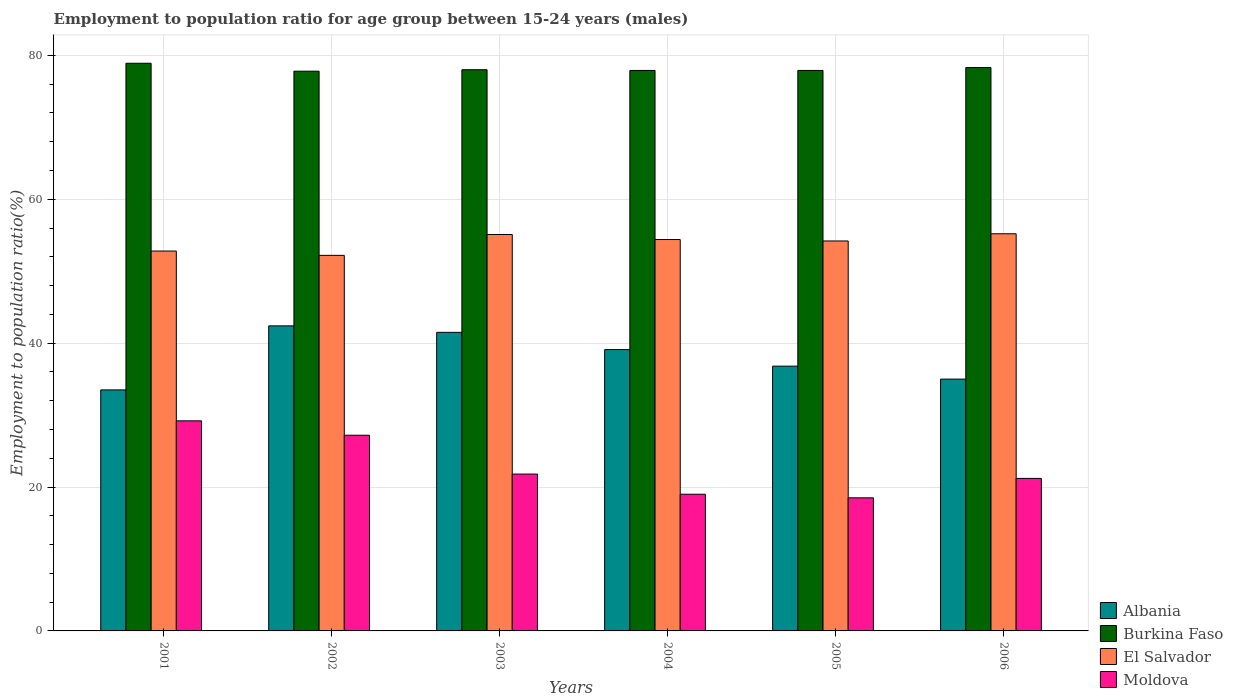How many different coloured bars are there?
Your response must be concise. 4. Are the number of bars per tick equal to the number of legend labels?
Your response must be concise. Yes. Are the number of bars on each tick of the X-axis equal?
Your answer should be very brief. Yes. How many bars are there on the 6th tick from the left?
Your response must be concise. 4. How many bars are there on the 1st tick from the right?
Give a very brief answer. 4. What is the employment to population ratio in Moldova in 2001?
Give a very brief answer. 29.2. Across all years, what is the maximum employment to population ratio in Burkina Faso?
Give a very brief answer. 78.9. Across all years, what is the minimum employment to population ratio in El Salvador?
Your answer should be very brief. 52.2. In which year was the employment to population ratio in Albania maximum?
Your response must be concise. 2002. In which year was the employment to population ratio in Moldova minimum?
Keep it short and to the point. 2005. What is the total employment to population ratio in Albania in the graph?
Offer a very short reply. 228.3. What is the difference between the employment to population ratio in El Salvador in 2001 and that in 2005?
Your response must be concise. -1.4. What is the difference between the employment to population ratio in Moldova in 2003 and the employment to population ratio in Burkina Faso in 2002?
Make the answer very short. -56. What is the average employment to population ratio in Albania per year?
Make the answer very short. 38.05. In the year 2005, what is the difference between the employment to population ratio in Burkina Faso and employment to population ratio in Moldova?
Provide a succinct answer. 59.4. What is the ratio of the employment to population ratio in Burkina Faso in 2001 to that in 2006?
Your answer should be very brief. 1.01. What is the difference between the highest and the second highest employment to population ratio in El Salvador?
Your answer should be very brief. 0.1. What is the difference between the highest and the lowest employment to population ratio in Albania?
Provide a short and direct response. 8.9. In how many years, is the employment to population ratio in Burkina Faso greater than the average employment to population ratio in Burkina Faso taken over all years?
Make the answer very short. 2. What does the 4th bar from the left in 2001 represents?
Offer a very short reply. Moldova. What does the 4th bar from the right in 2005 represents?
Offer a very short reply. Albania. How many bars are there?
Ensure brevity in your answer.  24. Are all the bars in the graph horizontal?
Your response must be concise. No. How many years are there in the graph?
Provide a succinct answer. 6. Are the values on the major ticks of Y-axis written in scientific E-notation?
Provide a short and direct response. No. Does the graph contain any zero values?
Offer a very short reply. No. Does the graph contain grids?
Your answer should be compact. Yes. What is the title of the graph?
Provide a short and direct response. Employment to population ratio for age group between 15-24 years (males). What is the label or title of the X-axis?
Your answer should be very brief. Years. What is the label or title of the Y-axis?
Give a very brief answer. Employment to population ratio(%). What is the Employment to population ratio(%) in Albania in 2001?
Provide a short and direct response. 33.5. What is the Employment to population ratio(%) in Burkina Faso in 2001?
Ensure brevity in your answer.  78.9. What is the Employment to population ratio(%) of El Salvador in 2001?
Offer a terse response. 52.8. What is the Employment to population ratio(%) in Moldova in 2001?
Provide a succinct answer. 29.2. What is the Employment to population ratio(%) of Albania in 2002?
Your answer should be compact. 42.4. What is the Employment to population ratio(%) of Burkina Faso in 2002?
Provide a short and direct response. 77.8. What is the Employment to population ratio(%) of El Salvador in 2002?
Your answer should be compact. 52.2. What is the Employment to population ratio(%) of Moldova in 2002?
Make the answer very short. 27.2. What is the Employment to population ratio(%) in Albania in 2003?
Keep it short and to the point. 41.5. What is the Employment to population ratio(%) in Burkina Faso in 2003?
Your answer should be very brief. 78. What is the Employment to population ratio(%) of El Salvador in 2003?
Offer a terse response. 55.1. What is the Employment to population ratio(%) of Moldova in 2003?
Keep it short and to the point. 21.8. What is the Employment to population ratio(%) of Albania in 2004?
Make the answer very short. 39.1. What is the Employment to population ratio(%) of Burkina Faso in 2004?
Your response must be concise. 77.9. What is the Employment to population ratio(%) of El Salvador in 2004?
Provide a short and direct response. 54.4. What is the Employment to population ratio(%) in Moldova in 2004?
Your response must be concise. 19. What is the Employment to population ratio(%) in Albania in 2005?
Give a very brief answer. 36.8. What is the Employment to population ratio(%) in Burkina Faso in 2005?
Keep it short and to the point. 77.9. What is the Employment to population ratio(%) of El Salvador in 2005?
Your answer should be very brief. 54.2. What is the Employment to population ratio(%) in Albania in 2006?
Make the answer very short. 35. What is the Employment to population ratio(%) in Burkina Faso in 2006?
Keep it short and to the point. 78.3. What is the Employment to population ratio(%) in El Salvador in 2006?
Make the answer very short. 55.2. What is the Employment to population ratio(%) in Moldova in 2006?
Your answer should be compact. 21.2. Across all years, what is the maximum Employment to population ratio(%) of Albania?
Make the answer very short. 42.4. Across all years, what is the maximum Employment to population ratio(%) of Burkina Faso?
Give a very brief answer. 78.9. Across all years, what is the maximum Employment to population ratio(%) of El Salvador?
Provide a short and direct response. 55.2. Across all years, what is the maximum Employment to population ratio(%) in Moldova?
Make the answer very short. 29.2. Across all years, what is the minimum Employment to population ratio(%) of Albania?
Offer a very short reply. 33.5. Across all years, what is the minimum Employment to population ratio(%) in Burkina Faso?
Ensure brevity in your answer.  77.8. Across all years, what is the minimum Employment to population ratio(%) of El Salvador?
Your answer should be compact. 52.2. What is the total Employment to population ratio(%) of Albania in the graph?
Your response must be concise. 228.3. What is the total Employment to population ratio(%) of Burkina Faso in the graph?
Offer a very short reply. 468.8. What is the total Employment to population ratio(%) in El Salvador in the graph?
Your answer should be compact. 323.9. What is the total Employment to population ratio(%) in Moldova in the graph?
Give a very brief answer. 136.9. What is the difference between the Employment to population ratio(%) of Albania in 2001 and that in 2002?
Your answer should be very brief. -8.9. What is the difference between the Employment to population ratio(%) of Burkina Faso in 2001 and that in 2002?
Keep it short and to the point. 1.1. What is the difference between the Employment to population ratio(%) in Albania in 2001 and that in 2003?
Provide a short and direct response. -8. What is the difference between the Employment to population ratio(%) in El Salvador in 2001 and that in 2003?
Your response must be concise. -2.3. What is the difference between the Employment to population ratio(%) in Albania in 2001 and that in 2004?
Your answer should be very brief. -5.6. What is the difference between the Employment to population ratio(%) in Burkina Faso in 2001 and that in 2005?
Provide a succinct answer. 1. What is the difference between the Employment to population ratio(%) of Moldova in 2001 and that in 2005?
Provide a short and direct response. 10.7. What is the difference between the Employment to population ratio(%) in El Salvador in 2001 and that in 2006?
Provide a short and direct response. -2.4. What is the difference between the Employment to population ratio(%) of Burkina Faso in 2002 and that in 2003?
Keep it short and to the point. -0.2. What is the difference between the Employment to population ratio(%) of Albania in 2002 and that in 2004?
Make the answer very short. 3.3. What is the difference between the Employment to population ratio(%) of El Salvador in 2002 and that in 2004?
Offer a very short reply. -2.2. What is the difference between the Employment to population ratio(%) of Moldova in 2002 and that in 2004?
Provide a short and direct response. 8.2. What is the difference between the Employment to population ratio(%) of Burkina Faso in 2002 and that in 2005?
Provide a succinct answer. -0.1. What is the difference between the Employment to population ratio(%) in El Salvador in 2002 and that in 2006?
Offer a very short reply. -3. What is the difference between the Employment to population ratio(%) of Moldova in 2002 and that in 2006?
Offer a very short reply. 6. What is the difference between the Employment to population ratio(%) of Albania in 2003 and that in 2004?
Keep it short and to the point. 2.4. What is the difference between the Employment to population ratio(%) in Albania in 2003 and that in 2005?
Your answer should be very brief. 4.7. What is the difference between the Employment to population ratio(%) in Moldova in 2003 and that in 2005?
Offer a terse response. 3.3. What is the difference between the Employment to population ratio(%) of Albania in 2003 and that in 2006?
Your answer should be very brief. 6.5. What is the difference between the Employment to population ratio(%) in Burkina Faso in 2003 and that in 2006?
Provide a succinct answer. -0.3. What is the difference between the Employment to population ratio(%) in El Salvador in 2003 and that in 2006?
Offer a very short reply. -0.1. What is the difference between the Employment to population ratio(%) in Albania in 2004 and that in 2005?
Give a very brief answer. 2.3. What is the difference between the Employment to population ratio(%) of Moldova in 2004 and that in 2005?
Ensure brevity in your answer.  0.5. What is the difference between the Employment to population ratio(%) of Burkina Faso in 2004 and that in 2006?
Offer a very short reply. -0.4. What is the difference between the Employment to population ratio(%) of El Salvador in 2004 and that in 2006?
Your answer should be compact. -0.8. What is the difference between the Employment to population ratio(%) of Albania in 2005 and that in 2006?
Keep it short and to the point. 1.8. What is the difference between the Employment to population ratio(%) in Burkina Faso in 2005 and that in 2006?
Offer a very short reply. -0.4. What is the difference between the Employment to population ratio(%) of Moldova in 2005 and that in 2006?
Offer a very short reply. -2.7. What is the difference between the Employment to population ratio(%) in Albania in 2001 and the Employment to population ratio(%) in Burkina Faso in 2002?
Your answer should be compact. -44.3. What is the difference between the Employment to population ratio(%) of Albania in 2001 and the Employment to population ratio(%) of El Salvador in 2002?
Make the answer very short. -18.7. What is the difference between the Employment to population ratio(%) in Albania in 2001 and the Employment to population ratio(%) in Moldova in 2002?
Offer a very short reply. 6.3. What is the difference between the Employment to population ratio(%) in Burkina Faso in 2001 and the Employment to population ratio(%) in El Salvador in 2002?
Your answer should be compact. 26.7. What is the difference between the Employment to population ratio(%) of Burkina Faso in 2001 and the Employment to population ratio(%) of Moldova in 2002?
Offer a terse response. 51.7. What is the difference between the Employment to population ratio(%) of El Salvador in 2001 and the Employment to population ratio(%) of Moldova in 2002?
Offer a terse response. 25.6. What is the difference between the Employment to population ratio(%) in Albania in 2001 and the Employment to population ratio(%) in Burkina Faso in 2003?
Your response must be concise. -44.5. What is the difference between the Employment to population ratio(%) in Albania in 2001 and the Employment to population ratio(%) in El Salvador in 2003?
Your answer should be very brief. -21.6. What is the difference between the Employment to population ratio(%) in Albania in 2001 and the Employment to population ratio(%) in Moldova in 2003?
Ensure brevity in your answer.  11.7. What is the difference between the Employment to population ratio(%) in Burkina Faso in 2001 and the Employment to population ratio(%) in El Salvador in 2003?
Your response must be concise. 23.8. What is the difference between the Employment to population ratio(%) in Burkina Faso in 2001 and the Employment to population ratio(%) in Moldova in 2003?
Your answer should be very brief. 57.1. What is the difference between the Employment to population ratio(%) of Albania in 2001 and the Employment to population ratio(%) of Burkina Faso in 2004?
Offer a very short reply. -44.4. What is the difference between the Employment to population ratio(%) in Albania in 2001 and the Employment to population ratio(%) in El Salvador in 2004?
Make the answer very short. -20.9. What is the difference between the Employment to population ratio(%) of Burkina Faso in 2001 and the Employment to population ratio(%) of El Salvador in 2004?
Offer a very short reply. 24.5. What is the difference between the Employment to population ratio(%) in Burkina Faso in 2001 and the Employment to population ratio(%) in Moldova in 2004?
Your answer should be very brief. 59.9. What is the difference between the Employment to population ratio(%) in El Salvador in 2001 and the Employment to population ratio(%) in Moldova in 2004?
Ensure brevity in your answer.  33.8. What is the difference between the Employment to population ratio(%) in Albania in 2001 and the Employment to population ratio(%) in Burkina Faso in 2005?
Provide a succinct answer. -44.4. What is the difference between the Employment to population ratio(%) of Albania in 2001 and the Employment to population ratio(%) of El Salvador in 2005?
Your answer should be very brief. -20.7. What is the difference between the Employment to population ratio(%) of Burkina Faso in 2001 and the Employment to population ratio(%) of El Salvador in 2005?
Your answer should be very brief. 24.7. What is the difference between the Employment to population ratio(%) in Burkina Faso in 2001 and the Employment to population ratio(%) in Moldova in 2005?
Your response must be concise. 60.4. What is the difference between the Employment to population ratio(%) of El Salvador in 2001 and the Employment to population ratio(%) of Moldova in 2005?
Give a very brief answer. 34.3. What is the difference between the Employment to population ratio(%) in Albania in 2001 and the Employment to population ratio(%) in Burkina Faso in 2006?
Your answer should be very brief. -44.8. What is the difference between the Employment to population ratio(%) in Albania in 2001 and the Employment to population ratio(%) in El Salvador in 2006?
Your answer should be compact. -21.7. What is the difference between the Employment to population ratio(%) in Burkina Faso in 2001 and the Employment to population ratio(%) in El Salvador in 2006?
Your response must be concise. 23.7. What is the difference between the Employment to population ratio(%) of Burkina Faso in 2001 and the Employment to population ratio(%) of Moldova in 2006?
Your answer should be very brief. 57.7. What is the difference between the Employment to population ratio(%) in El Salvador in 2001 and the Employment to population ratio(%) in Moldova in 2006?
Your response must be concise. 31.6. What is the difference between the Employment to population ratio(%) of Albania in 2002 and the Employment to population ratio(%) of Burkina Faso in 2003?
Ensure brevity in your answer.  -35.6. What is the difference between the Employment to population ratio(%) of Albania in 2002 and the Employment to population ratio(%) of El Salvador in 2003?
Keep it short and to the point. -12.7. What is the difference between the Employment to population ratio(%) of Albania in 2002 and the Employment to population ratio(%) of Moldova in 2003?
Offer a terse response. 20.6. What is the difference between the Employment to population ratio(%) in Burkina Faso in 2002 and the Employment to population ratio(%) in El Salvador in 2003?
Your answer should be compact. 22.7. What is the difference between the Employment to population ratio(%) in Burkina Faso in 2002 and the Employment to population ratio(%) in Moldova in 2003?
Offer a terse response. 56. What is the difference between the Employment to population ratio(%) of El Salvador in 2002 and the Employment to population ratio(%) of Moldova in 2003?
Your answer should be very brief. 30.4. What is the difference between the Employment to population ratio(%) in Albania in 2002 and the Employment to population ratio(%) in Burkina Faso in 2004?
Your answer should be very brief. -35.5. What is the difference between the Employment to population ratio(%) in Albania in 2002 and the Employment to population ratio(%) in El Salvador in 2004?
Offer a terse response. -12. What is the difference between the Employment to population ratio(%) in Albania in 2002 and the Employment to population ratio(%) in Moldova in 2004?
Make the answer very short. 23.4. What is the difference between the Employment to population ratio(%) in Burkina Faso in 2002 and the Employment to population ratio(%) in El Salvador in 2004?
Provide a succinct answer. 23.4. What is the difference between the Employment to population ratio(%) in Burkina Faso in 2002 and the Employment to population ratio(%) in Moldova in 2004?
Give a very brief answer. 58.8. What is the difference between the Employment to population ratio(%) of El Salvador in 2002 and the Employment to population ratio(%) of Moldova in 2004?
Your answer should be very brief. 33.2. What is the difference between the Employment to population ratio(%) of Albania in 2002 and the Employment to population ratio(%) of Burkina Faso in 2005?
Provide a short and direct response. -35.5. What is the difference between the Employment to population ratio(%) in Albania in 2002 and the Employment to population ratio(%) in El Salvador in 2005?
Provide a short and direct response. -11.8. What is the difference between the Employment to population ratio(%) in Albania in 2002 and the Employment to population ratio(%) in Moldova in 2005?
Provide a succinct answer. 23.9. What is the difference between the Employment to population ratio(%) in Burkina Faso in 2002 and the Employment to population ratio(%) in El Salvador in 2005?
Make the answer very short. 23.6. What is the difference between the Employment to population ratio(%) in Burkina Faso in 2002 and the Employment to population ratio(%) in Moldova in 2005?
Make the answer very short. 59.3. What is the difference between the Employment to population ratio(%) of El Salvador in 2002 and the Employment to population ratio(%) of Moldova in 2005?
Provide a short and direct response. 33.7. What is the difference between the Employment to population ratio(%) in Albania in 2002 and the Employment to population ratio(%) in Burkina Faso in 2006?
Make the answer very short. -35.9. What is the difference between the Employment to population ratio(%) in Albania in 2002 and the Employment to population ratio(%) in El Salvador in 2006?
Provide a short and direct response. -12.8. What is the difference between the Employment to population ratio(%) of Albania in 2002 and the Employment to population ratio(%) of Moldova in 2006?
Provide a short and direct response. 21.2. What is the difference between the Employment to population ratio(%) of Burkina Faso in 2002 and the Employment to population ratio(%) of El Salvador in 2006?
Provide a succinct answer. 22.6. What is the difference between the Employment to population ratio(%) in Burkina Faso in 2002 and the Employment to population ratio(%) in Moldova in 2006?
Provide a succinct answer. 56.6. What is the difference between the Employment to population ratio(%) of Albania in 2003 and the Employment to population ratio(%) of Burkina Faso in 2004?
Your answer should be compact. -36.4. What is the difference between the Employment to population ratio(%) in Albania in 2003 and the Employment to population ratio(%) in Moldova in 2004?
Make the answer very short. 22.5. What is the difference between the Employment to population ratio(%) of Burkina Faso in 2003 and the Employment to population ratio(%) of El Salvador in 2004?
Give a very brief answer. 23.6. What is the difference between the Employment to population ratio(%) of El Salvador in 2003 and the Employment to population ratio(%) of Moldova in 2004?
Provide a short and direct response. 36.1. What is the difference between the Employment to population ratio(%) in Albania in 2003 and the Employment to population ratio(%) in Burkina Faso in 2005?
Give a very brief answer. -36.4. What is the difference between the Employment to population ratio(%) of Burkina Faso in 2003 and the Employment to population ratio(%) of El Salvador in 2005?
Ensure brevity in your answer.  23.8. What is the difference between the Employment to population ratio(%) of Burkina Faso in 2003 and the Employment to population ratio(%) of Moldova in 2005?
Keep it short and to the point. 59.5. What is the difference between the Employment to population ratio(%) of El Salvador in 2003 and the Employment to population ratio(%) of Moldova in 2005?
Provide a short and direct response. 36.6. What is the difference between the Employment to population ratio(%) of Albania in 2003 and the Employment to population ratio(%) of Burkina Faso in 2006?
Keep it short and to the point. -36.8. What is the difference between the Employment to population ratio(%) of Albania in 2003 and the Employment to population ratio(%) of El Salvador in 2006?
Keep it short and to the point. -13.7. What is the difference between the Employment to population ratio(%) in Albania in 2003 and the Employment to population ratio(%) in Moldova in 2006?
Ensure brevity in your answer.  20.3. What is the difference between the Employment to population ratio(%) in Burkina Faso in 2003 and the Employment to population ratio(%) in El Salvador in 2006?
Keep it short and to the point. 22.8. What is the difference between the Employment to population ratio(%) in Burkina Faso in 2003 and the Employment to population ratio(%) in Moldova in 2006?
Offer a very short reply. 56.8. What is the difference between the Employment to population ratio(%) in El Salvador in 2003 and the Employment to population ratio(%) in Moldova in 2006?
Keep it short and to the point. 33.9. What is the difference between the Employment to population ratio(%) in Albania in 2004 and the Employment to population ratio(%) in Burkina Faso in 2005?
Give a very brief answer. -38.8. What is the difference between the Employment to population ratio(%) in Albania in 2004 and the Employment to population ratio(%) in El Salvador in 2005?
Your answer should be compact. -15.1. What is the difference between the Employment to population ratio(%) in Albania in 2004 and the Employment to population ratio(%) in Moldova in 2005?
Give a very brief answer. 20.6. What is the difference between the Employment to population ratio(%) in Burkina Faso in 2004 and the Employment to population ratio(%) in El Salvador in 2005?
Ensure brevity in your answer.  23.7. What is the difference between the Employment to population ratio(%) in Burkina Faso in 2004 and the Employment to population ratio(%) in Moldova in 2005?
Keep it short and to the point. 59.4. What is the difference between the Employment to population ratio(%) in El Salvador in 2004 and the Employment to population ratio(%) in Moldova in 2005?
Your answer should be very brief. 35.9. What is the difference between the Employment to population ratio(%) of Albania in 2004 and the Employment to population ratio(%) of Burkina Faso in 2006?
Ensure brevity in your answer.  -39.2. What is the difference between the Employment to population ratio(%) of Albania in 2004 and the Employment to population ratio(%) of El Salvador in 2006?
Ensure brevity in your answer.  -16.1. What is the difference between the Employment to population ratio(%) of Burkina Faso in 2004 and the Employment to population ratio(%) of El Salvador in 2006?
Offer a terse response. 22.7. What is the difference between the Employment to population ratio(%) of Burkina Faso in 2004 and the Employment to population ratio(%) of Moldova in 2006?
Offer a very short reply. 56.7. What is the difference between the Employment to population ratio(%) in El Salvador in 2004 and the Employment to population ratio(%) in Moldova in 2006?
Provide a succinct answer. 33.2. What is the difference between the Employment to population ratio(%) in Albania in 2005 and the Employment to population ratio(%) in Burkina Faso in 2006?
Keep it short and to the point. -41.5. What is the difference between the Employment to population ratio(%) of Albania in 2005 and the Employment to population ratio(%) of El Salvador in 2006?
Give a very brief answer. -18.4. What is the difference between the Employment to population ratio(%) in Burkina Faso in 2005 and the Employment to population ratio(%) in El Salvador in 2006?
Provide a succinct answer. 22.7. What is the difference between the Employment to population ratio(%) of Burkina Faso in 2005 and the Employment to population ratio(%) of Moldova in 2006?
Offer a very short reply. 56.7. What is the difference between the Employment to population ratio(%) of El Salvador in 2005 and the Employment to population ratio(%) of Moldova in 2006?
Offer a very short reply. 33. What is the average Employment to population ratio(%) of Albania per year?
Offer a very short reply. 38.05. What is the average Employment to population ratio(%) in Burkina Faso per year?
Your answer should be compact. 78.13. What is the average Employment to population ratio(%) in El Salvador per year?
Provide a short and direct response. 53.98. What is the average Employment to population ratio(%) of Moldova per year?
Offer a very short reply. 22.82. In the year 2001, what is the difference between the Employment to population ratio(%) in Albania and Employment to population ratio(%) in Burkina Faso?
Provide a succinct answer. -45.4. In the year 2001, what is the difference between the Employment to population ratio(%) of Albania and Employment to population ratio(%) of El Salvador?
Offer a terse response. -19.3. In the year 2001, what is the difference between the Employment to population ratio(%) of Albania and Employment to population ratio(%) of Moldova?
Provide a succinct answer. 4.3. In the year 2001, what is the difference between the Employment to population ratio(%) in Burkina Faso and Employment to population ratio(%) in El Salvador?
Keep it short and to the point. 26.1. In the year 2001, what is the difference between the Employment to population ratio(%) of Burkina Faso and Employment to population ratio(%) of Moldova?
Ensure brevity in your answer.  49.7. In the year 2001, what is the difference between the Employment to population ratio(%) in El Salvador and Employment to population ratio(%) in Moldova?
Your answer should be very brief. 23.6. In the year 2002, what is the difference between the Employment to population ratio(%) in Albania and Employment to population ratio(%) in Burkina Faso?
Give a very brief answer. -35.4. In the year 2002, what is the difference between the Employment to population ratio(%) in Albania and Employment to population ratio(%) in Moldova?
Your answer should be compact. 15.2. In the year 2002, what is the difference between the Employment to population ratio(%) in Burkina Faso and Employment to population ratio(%) in El Salvador?
Offer a very short reply. 25.6. In the year 2002, what is the difference between the Employment to population ratio(%) in Burkina Faso and Employment to population ratio(%) in Moldova?
Your response must be concise. 50.6. In the year 2002, what is the difference between the Employment to population ratio(%) in El Salvador and Employment to population ratio(%) in Moldova?
Offer a terse response. 25. In the year 2003, what is the difference between the Employment to population ratio(%) in Albania and Employment to population ratio(%) in Burkina Faso?
Give a very brief answer. -36.5. In the year 2003, what is the difference between the Employment to population ratio(%) of Albania and Employment to population ratio(%) of El Salvador?
Make the answer very short. -13.6. In the year 2003, what is the difference between the Employment to population ratio(%) of Albania and Employment to population ratio(%) of Moldova?
Offer a very short reply. 19.7. In the year 2003, what is the difference between the Employment to population ratio(%) of Burkina Faso and Employment to population ratio(%) of El Salvador?
Offer a very short reply. 22.9. In the year 2003, what is the difference between the Employment to population ratio(%) of Burkina Faso and Employment to population ratio(%) of Moldova?
Your answer should be compact. 56.2. In the year 2003, what is the difference between the Employment to population ratio(%) in El Salvador and Employment to population ratio(%) in Moldova?
Offer a terse response. 33.3. In the year 2004, what is the difference between the Employment to population ratio(%) in Albania and Employment to population ratio(%) in Burkina Faso?
Keep it short and to the point. -38.8. In the year 2004, what is the difference between the Employment to population ratio(%) of Albania and Employment to population ratio(%) of El Salvador?
Give a very brief answer. -15.3. In the year 2004, what is the difference between the Employment to population ratio(%) in Albania and Employment to population ratio(%) in Moldova?
Provide a succinct answer. 20.1. In the year 2004, what is the difference between the Employment to population ratio(%) in Burkina Faso and Employment to population ratio(%) in Moldova?
Offer a terse response. 58.9. In the year 2004, what is the difference between the Employment to population ratio(%) in El Salvador and Employment to population ratio(%) in Moldova?
Your response must be concise. 35.4. In the year 2005, what is the difference between the Employment to population ratio(%) of Albania and Employment to population ratio(%) of Burkina Faso?
Make the answer very short. -41.1. In the year 2005, what is the difference between the Employment to population ratio(%) in Albania and Employment to population ratio(%) in El Salvador?
Your answer should be very brief. -17.4. In the year 2005, what is the difference between the Employment to population ratio(%) of Burkina Faso and Employment to population ratio(%) of El Salvador?
Ensure brevity in your answer.  23.7. In the year 2005, what is the difference between the Employment to population ratio(%) of Burkina Faso and Employment to population ratio(%) of Moldova?
Provide a short and direct response. 59.4. In the year 2005, what is the difference between the Employment to population ratio(%) of El Salvador and Employment to population ratio(%) of Moldova?
Your answer should be very brief. 35.7. In the year 2006, what is the difference between the Employment to population ratio(%) of Albania and Employment to population ratio(%) of Burkina Faso?
Offer a terse response. -43.3. In the year 2006, what is the difference between the Employment to population ratio(%) in Albania and Employment to population ratio(%) in El Salvador?
Ensure brevity in your answer.  -20.2. In the year 2006, what is the difference between the Employment to population ratio(%) of Albania and Employment to population ratio(%) of Moldova?
Give a very brief answer. 13.8. In the year 2006, what is the difference between the Employment to population ratio(%) of Burkina Faso and Employment to population ratio(%) of El Salvador?
Give a very brief answer. 23.1. In the year 2006, what is the difference between the Employment to population ratio(%) of Burkina Faso and Employment to population ratio(%) of Moldova?
Keep it short and to the point. 57.1. In the year 2006, what is the difference between the Employment to population ratio(%) of El Salvador and Employment to population ratio(%) of Moldova?
Offer a terse response. 34. What is the ratio of the Employment to population ratio(%) in Albania in 2001 to that in 2002?
Keep it short and to the point. 0.79. What is the ratio of the Employment to population ratio(%) of Burkina Faso in 2001 to that in 2002?
Offer a terse response. 1.01. What is the ratio of the Employment to population ratio(%) in El Salvador in 2001 to that in 2002?
Your response must be concise. 1.01. What is the ratio of the Employment to population ratio(%) in Moldova in 2001 to that in 2002?
Offer a very short reply. 1.07. What is the ratio of the Employment to population ratio(%) of Albania in 2001 to that in 2003?
Ensure brevity in your answer.  0.81. What is the ratio of the Employment to population ratio(%) in Burkina Faso in 2001 to that in 2003?
Give a very brief answer. 1.01. What is the ratio of the Employment to population ratio(%) in El Salvador in 2001 to that in 2003?
Your response must be concise. 0.96. What is the ratio of the Employment to population ratio(%) of Moldova in 2001 to that in 2003?
Your answer should be very brief. 1.34. What is the ratio of the Employment to population ratio(%) in Albania in 2001 to that in 2004?
Give a very brief answer. 0.86. What is the ratio of the Employment to population ratio(%) of Burkina Faso in 2001 to that in 2004?
Provide a short and direct response. 1.01. What is the ratio of the Employment to population ratio(%) in El Salvador in 2001 to that in 2004?
Make the answer very short. 0.97. What is the ratio of the Employment to population ratio(%) in Moldova in 2001 to that in 2004?
Your response must be concise. 1.54. What is the ratio of the Employment to population ratio(%) in Albania in 2001 to that in 2005?
Provide a succinct answer. 0.91. What is the ratio of the Employment to population ratio(%) in Burkina Faso in 2001 to that in 2005?
Offer a terse response. 1.01. What is the ratio of the Employment to population ratio(%) of El Salvador in 2001 to that in 2005?
Make the answer very short. 0.97. What is the ratio of the Employment to population ratio(%) in Moldova in 2001 to that in 2005?
Your response must be concise. 1.58. What is the ratio of the Employment to population ratio(%) in Albania in 2001 to that in 2006?
Offer a very short reply. 0.96. What is the ratio of the Employment to population ratio(%) in Burkina Faso in 2001 to that in 2006?
Your answer should be very brief. 1.01. What is the ratio of the Employment to population ratio(%) of El Salvador in 2001 to that in 2006?
Give a very brief answer. 0.96. What is the ratio of the Employment to population ratio(%) in Moldova in 2001 to that in 2006?
Your response must be concise. 1.38. What is the ratio of the Employment to population ratio(%) of Albania in 2002 to that in 2003?
Your answer should be compact. 1.02. What is the ratio of the Employment to population ratio(%) of Moldova in 2002 to that in 2003?
Provide a succinct answer. 1.25. What is the ratio of the Employment to population ratio(%) in Albania in 2002 to that in 2004?
Ensure brevity in your answer.  1.08. What is the ratio of the Employment to population ratio(%) in El Salvador in 2002 to that in 2004?
Provide a short and direct response. 0.96. What is the ratio of the Employment to population ratio(%) of Moldova in 2002 to that in 2004?
Your response must be concise. 1.43. What is the ratio of the Employment to population ratio(%) of Albania in 2002 to that in 2005?
Your response must be concise. 1.15. What is the ratio of the Employment to population ratio(%) of Burkina Faso in 2002 to that in 2005?
Provide a succinct answer. 1. What is the ratio of the Employment to population ratio(%) of El Salvador in 2002 to that in 2005?
Provide a short and direct response. 0.96. What is the ratio of the Employment to population ratio(%) in Moldova in 2002 to that in 2005?
Offer a terse response. 1.47. What is the ratio of the Employment to population ratio(%) of Albania in 2002 to that in 2006?
Your answer should be compact. 1.21. What is the ratio of the Employment to population ratio(%) of Burkina Faso in 2002 to that in 2006?
Give a very brief answer. 0.99. What is the ratio of the Employment to population ratio(%) of El Salvador in 2002 to that in 2006?
Offer a very short reply. 0.95. What is the ratio of the Employment to population ratio(%) in Moldova in 2002 to that in 2006?
Your response must be concise. 1.28. What is the ratio of the Employment to population ratio(%) in Albania in 2003 to that in 2004?
Keep it short and to the point. 1.06. What is the ratio of the Employment to population ratio(%) of Burkina Faso in 2003 to that in 2004?
Your answer should be very brief. 1. What is the ratio of the Employment to population ratio(%) of El Salvador in 2003 to that in 2004?
Offer a terse response. 1.01. What is the ratio of the Employment to population ratio(%) of Moldova in 2003 to that in 2004?
Your answer should be very brief. 1.15. What is the ratio of the Employment to population ratio(%) of Albania in 2003 to that in 2005?
Keep it short and to the point. 1.13. What is the ratio of the Employment to population ratio(%) in Burkina Faso in 2003 to that in 2005?
Make the answer very short. 1. What is the ratio of the Employment to population ratio(%) in El Salvador in 2003 to that in 2005?
Ensure brevity in your answer.  1.02. What is the ratio of the Employment to population ratio(%) of Moldova in 2003 to that in 2005?
Provide a short and direct response. 1.18. What is the ratio of the Employment to population ratio(%) of Albania in 2003 to that in 2006?
Give a very brief answer. 1.19. What is the ratio of the Employment to population ratio(%) in Burkina Faso in 2003 to that in 2006?
Offer a very short reply. 1. What is the ratio of the Employment to population ratio(%) in Moldova in 2003 to that in 2006?
Offer a very short reply. 1.03. What is the ratio of the Employment to population ratio(%) in Burkina Faso in 2004 to that in 2005?
Provide a short and direct response. 1. What is the ratio of the Employment to population ratio(%) of El Salvador in 2004 to that in 2005?
Make the answer very short. 1. What is the ratio of the Employment to population ratio(%) of Albania in 2004 to that in 2006?
Your answer should be compact. 1.12. What is the ratio of the Employment to population ratio(%) in Burkina Faso in 2004 to that in 2006?
Give a very brief answer. 0.99. What is the ratio of the Employment to population ratio(%) in El Salvador in 2004 to that in 2006?
Offer a very short reply. 0.99. What is the ratio of the Employment to population ratio(%) of Moldova in 2004 to that in 2006?
Your response must be concise. 0.9. What is the ratio of the Employment to population ratio(%) in Albania in 2005 to that in 2006?
Your answer should be compact. 1.05. What is the ratio of the Employment to population ratio(%) in El Salvador in 2005 to that in 2006?
Offer a very short reply. 0.98. What is the ratio of the Employment to population ratio(%) of Moldova in 2005 to that in 2006?
Keep it short and to the point. 0.87. What is the difference between the highest and the second highest Employment to population ratio(%) in Albania?
Your response must be concise. 0.9. What is the difference between the highest and the second highest Employment to population ratio(%) in El Salvador?
Provide a succinct answer. 0.1. What is the difference between the highest and the lowest Employment to population ratio(%) of Albania?
Your answer should be compact. 8.9. What is the difference between the highest and the lowest Employment to population ratio(%) in El Salvador?
Ensure brevity in your answer.  3. What is the difference between the highest and the lowest Employment to population ratio(%) in Moldova?
Your answer should be very brief. 10.7. 